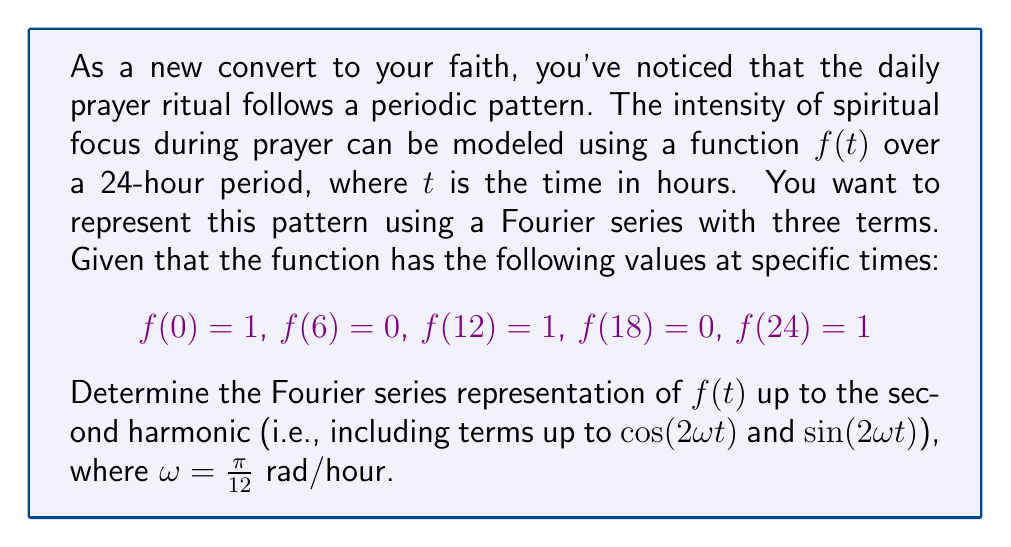Help me with this question. Let's approach this step-by-step:

1) The general form of a Fourier series up to the second harmonic is:

   $f(t) = a_0 + a_1\cos(\omega t) + b_1\sin(\omega t) + a_2\cos(2\omega t) + b_2\sin(2\omega t)$

   where $\omega = \frac{\pi}{12}$ rad/hour

2) Given the periodic nature and the values provided, we can deduce that:
   - The function has a period of 24 hours
   - It's symmetric about t = 0 and t = 12
   - It reaches its maximum at t = 0, 12, 24 and minimum at t = 6, 18

3) Due to the symmetry, we can conclude that $b_1 = b_2 = 0$ (as sine functions are odd)

4) Our simplified Fourier series becomes:

   $f(t) = a_0 + a_1\cos(\omega t) + a_2\cos(2\omega t)$

5) Now we can use the given values to create a system of equations:

   $f(0) = a_0 + a_1 + a_2 = 1$
   $f(6) = a_0 - a_1 + a_2 = 0$
   $f(12) = a_0 - a_1 + a_2 = 1$

6) From the second and third equations, we can deduce that $a_0 + a_2 = \frac{1}{2}$

7) Subtracting the second equation from the first:

   $2a_1 = 1$
   $a_1 = \frac{1}{2}$

8) Substituting this back into the first equation:

   $a_0 + \frac{1}{2} + a_2 = 1$
   $a_0 + a_2 = \frac{1}{2}$

9) We now have two equations:
   $a_0 + a_2 = \frac{1}{2}$
   $a_0 - a_1 + a_2 = 0$

   Subtracting the second from the first:
   $2a_1 = \frac{1}{2}$
   $a_1 = \frac{1}{4}$

10) Substituting back:
    $a_0 + a_2 = \frac{1}{2}$
    $a_0 + \frac{1}{4} = \frac{1}{2}$
    $a_0 = \frac{1}{4}$

    And consequently:
    $a_2 = \frac{1}{4}$

Therefore, the Fourier series representation is:

$f(t) = \frac{1}{4} + \frac{1}{2}\cos(\frac{\pi}{12}t) + \frac{1}{4}\cos(\frac{\pi}{6}t)$
Answer: $f(t) = \frac{1}{4} + \frac{1}{2}\cos(\frac{\pi}{12}t) + \frac{1}{4}\cos(\frac{\pi}{6}t)$ 